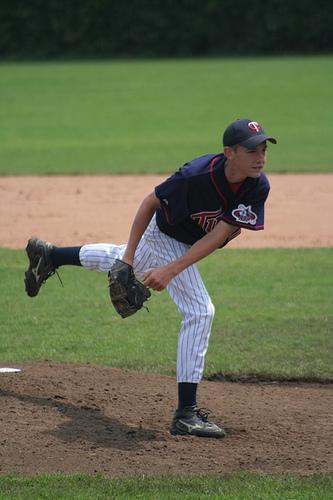How many keyboards are shown?
Give a very brief answer. 0. 